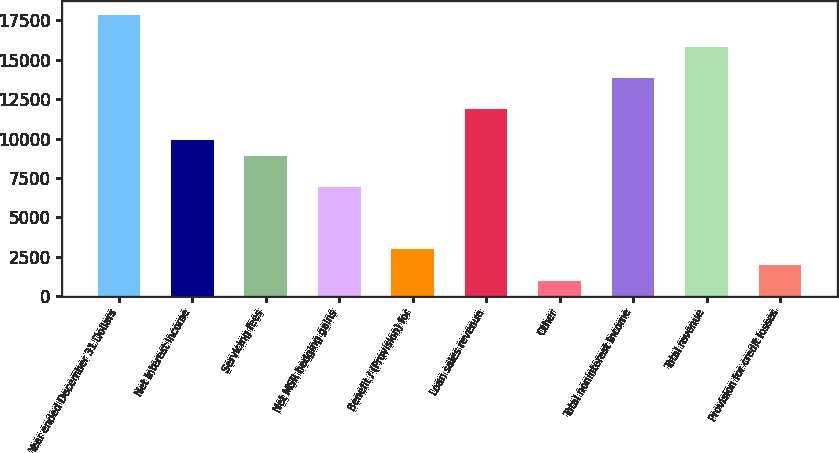Convert chart to OTSL. <chart><loc_0><loc_0><loc_500><loc_500><bar_chart><fcel>Year ended December 31 Dollars<fcel>Net interest income<fcel>Servicing fees<fcel>Net MSR hedging gains<fcel>Benefit / (Provision) for<fcel>Loan sales revenue<fcel>Other<fcel>Total noninterest income<fcel>Total revenue<fcel>Provision for credit losses<nl><fcel>17811.6<fcel>9896<fcel>8906.55<fcel>6927.65<fcel>2969.85<fcel>11874.9<fcel>990.95<fcel>13853.8<fcel>15832.7<fcel>1980.4<nl></chart> 